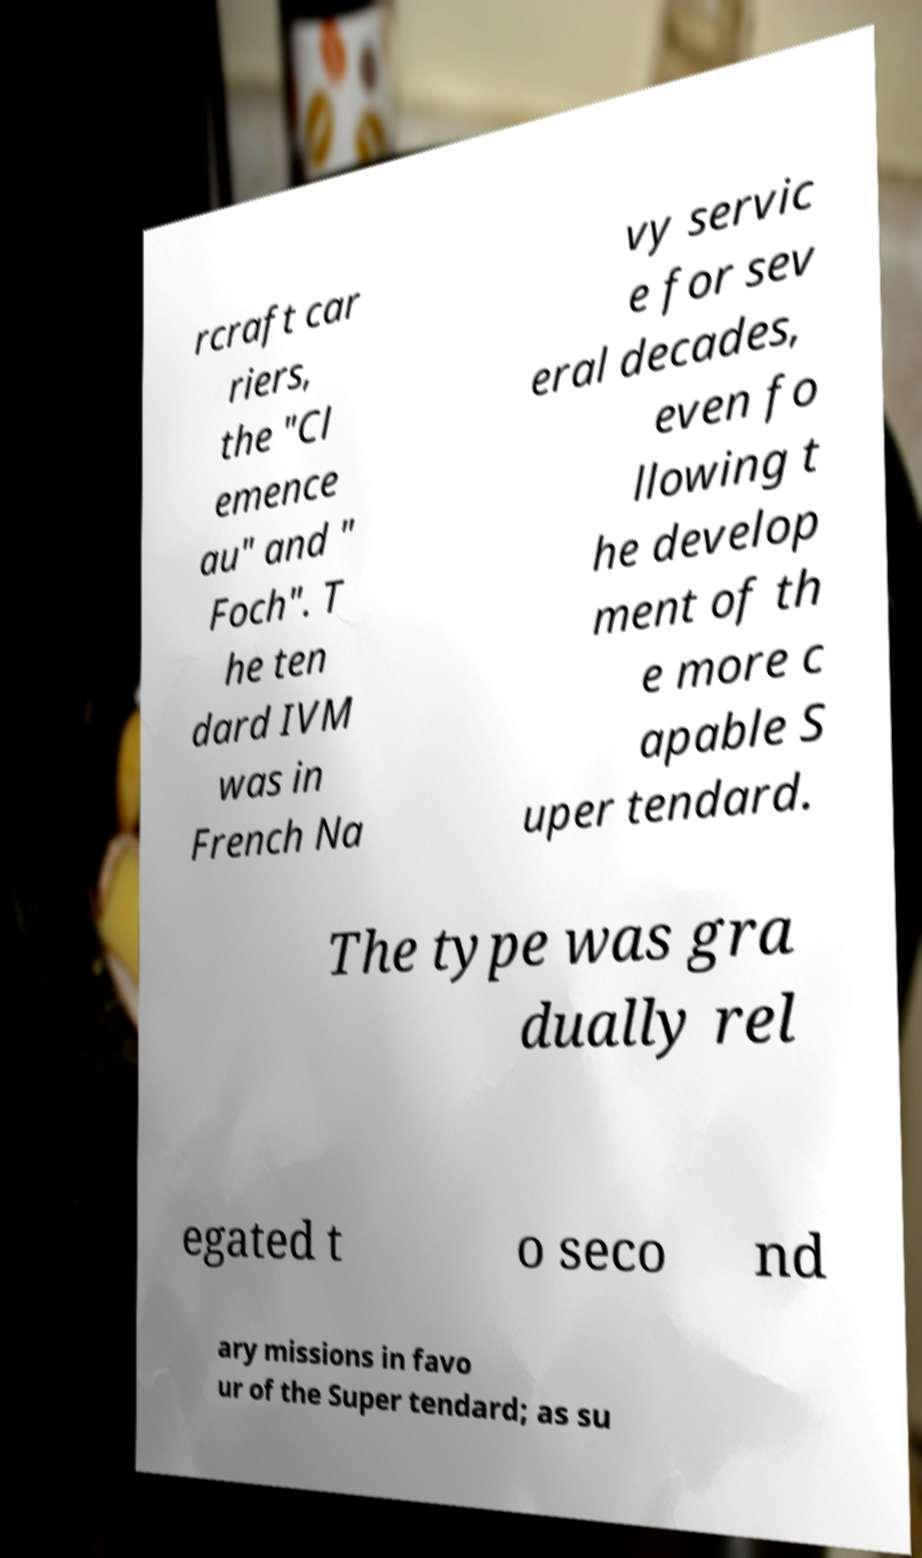Could you extract and type out the text from this image? rcraft car riers, the "Cl emence au" and " Foch". T he ten dard IVM was in French Na vy servic e for sev eral decades, even fo llowing t he develop ment of th e more c apable S uper tendard. The type was gra dually rel egated t o seco nd ary missions in favo ur of the Super tendard; as su 